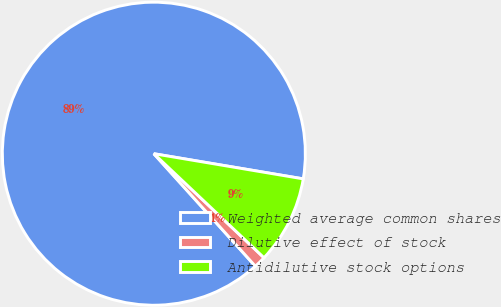Convert chart to OTSL. <chart><loc_0><loc_0><loc_500><loc_500><pie_chart><fcel>Weighted average common shares<fcel>Dilutive effect of stock<fcel>Antidilutive stock options<nl><fcel>89.34%<fcel>1.27%<fcel>9.39%<nl></chart> 